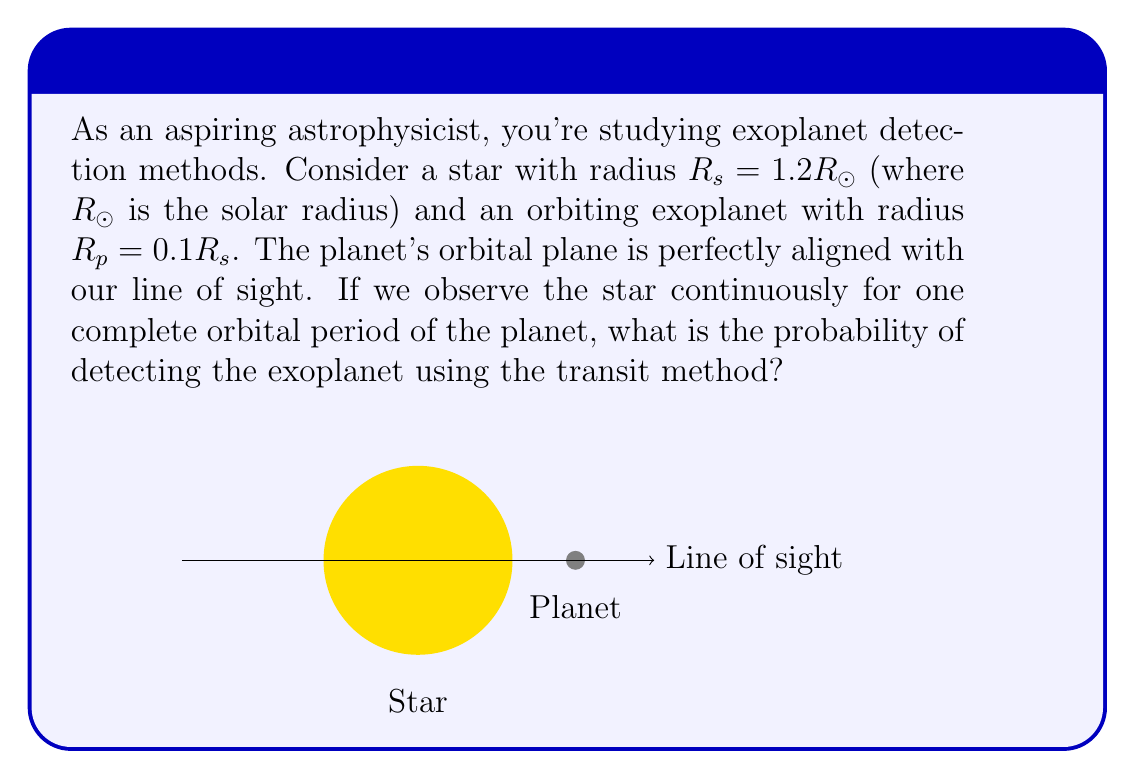Help me with this question. To solve this problem, we need to understand that the probability of detecting an exoplanet using the transit method is equal to the fraction of time the planet spends transiting the star's disk. This can be calculated as the ratio of the star's diameter to the circumference of the planet's orbit.

Step 1: Calculate the fraction of the orbit where a transit can occur.
The transit occurs when the planet is within one stellar radius of the center of its orbit, on either side of the star. This distance is equal to the star's diameter.

Step 2: Express the transit distance in terms of the star's radius.
Transit distance = $2R_s = 2 * 1.2R_\odot = 2.4R_\odot$

Step 3: Calculate the circumference of the planet's orbit.
We don't know the orbital radius, but we can express it in terms of the star's radius. Let's call the orbital radius $a$. The circumference is then $2\pi a$.

Step 4: Calculate the probability as the ratio of transit distance to orbit circumference.
$$P(\text{transit}) = \frac{\text{Transit distance}}{\text{Orbit circumference}} = \frac{2.4R_\odot}{2\pi a}$$

Step 5: Simplify the expression.
$$P(\text{transit}) = \frac{1.2R_\odot}{\pi a}$$

This is our final expression for the probability. Note that we can't calculate a numerical value without knowing the orbital radius $a$, but this formula gives us the probability in terms of the star's radius and the planet's orbital radius.
Answer: $P(\text{transit}) = \frac{1.2R_\odot}{\pi a}$ 